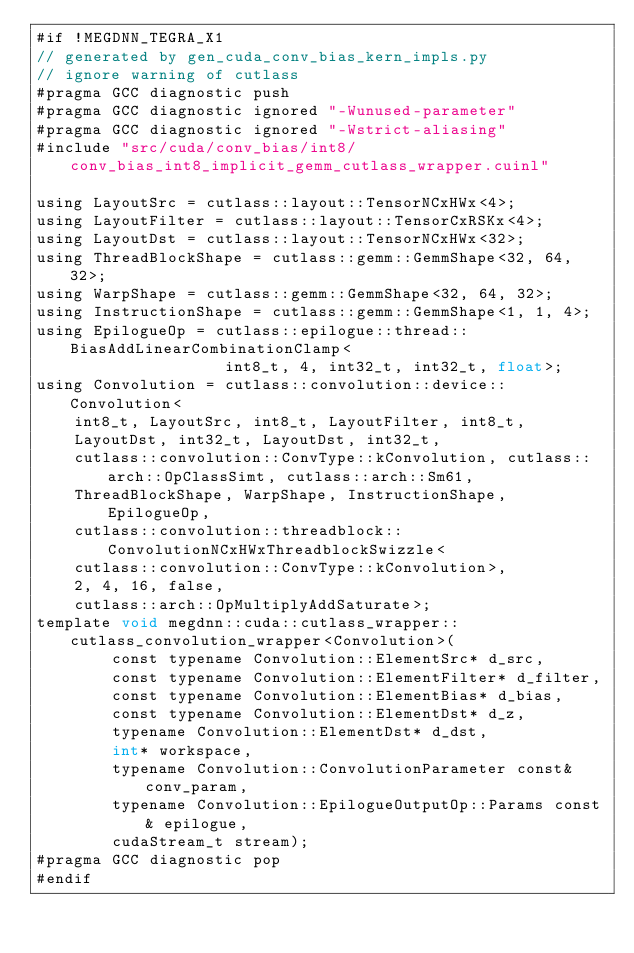<code> <loc_0><loc_0><loc_500><loc_500><_Cuda_>#if !MEGDNN_TEGRA_X1
// generated by gen_cuda_conv_bias_kern_impls.py
// ignore warning of cutlass
#pragma GCC diagnostic push
#pragma GCC diagnostic ignored "-Wunused-parameter"
#pragma GCC diagnostic ignored "-Wstrict-aliasing"
#include "src/cuda/conv_bias/int8/conv_bias_int8_implicit_gemm_cutlass_wrapper.cuinl"

using LayoutSrc = cutlass::layout::TensorNCxHWx<4>;
using LayoutFilter = cutlass::layout::TensorCxRSKx<4>;
using LayoutDst = cutlass::layout::TensorNCxHWx<32>;
using ThreadBlockShape = cutlass::gemm::GemmShape<32, 64, 32>;
using WarpShape = cutlass::gemm::GemmShape<32, 64, 32>;
using InstructionShape = cutlass::gemm::GemmShape<1, 1, 4>;
using EpilogueOp = cutlass::epilogue::thread::BiasAddLinearCombinationClamp<
                    int8_t, 4, int32_t, int32_t, float>;
using Convolution = cutlass::convolution::device::Convolution<
    int8_t, LayoutSrc, int8_t, LayoutFilter, int8_t, 
    LayoutDst, int32_t, LayoutDst, int32_t, 
    cutlass::convolution::ConvType::kConvolution, cutlass::arch::OpClassSimt, cutlass::arch::Sm61, 
    ThreadBlockShape, WarpShape, InstructionShape, EpilogueOp, 
    cutlass::convolution::threadblock::ConvolutionNCxHWxThreadblockSwizzle<
    cutlass::convolution::ConvType::kConvolution>, 
    2, 4, 16, false, 
    cutlass::arch::OpMultiplyAddSaturate>;
template void megdnn::cuda::cutlass_wrapper::cutlass_convolution_wrapper<Convolution>(
        const typename Convolution::ElementSrc* d_src, 
        const typename Convolution::ElementFilter* d_filter, 
        const typename Convolution::ElementBias* d_bias, 
        const typename Convolution::ElementDst* d_z, 
        typename Convolution::ElementDst* d_dst, 
        int* workspace, 
        typename Convolution::ConvolutionParameter const& conv_param, 
        typename Convolution::EpilogueOutputOp::Params const& epilogue, 
        cudaStream_t stream);
#pragma GCC diagnostic pop
#endif
</code> 